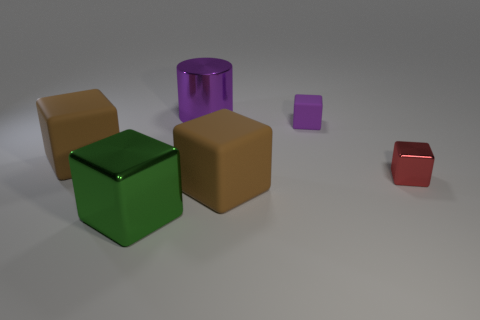Are there any small things to the right of the small purple object?
Your answer should be compact. Yes. What number of large things are either purple things or purple rubber things?
Keep it short and to the point. 1. Are the big cylinder and the small purple cube made of the same material?
Your answer should be very brief. No. There is a metallic cylinder that is the same color as the small rubber cube; what size is it?
Keep it short and to the point. Large. Is there a object of the same color as the small rubber cube?
Give a very brief answer. Yes. There is a purple thing that is the same material as the big green object; what size is it?
Keep it short and to the point. Large. There is a big shiny thing behind the brown rubber thing to the right of the brown block that is on the left side of the green thing; what is its shape?
Your response must be concise. Cylinder. What size is the red thing that is the same shape as the tiny purple rubber thing?
Provide a succinct answer. Small. How big is the thing that is in front of the tiny red metal block and on the right side of the purple cylinder?
Offer a very short reply. Large. There is a big shiny object that is the same color as the small matte thing; what shape is it?
Your response must be concise. Cylinder. 